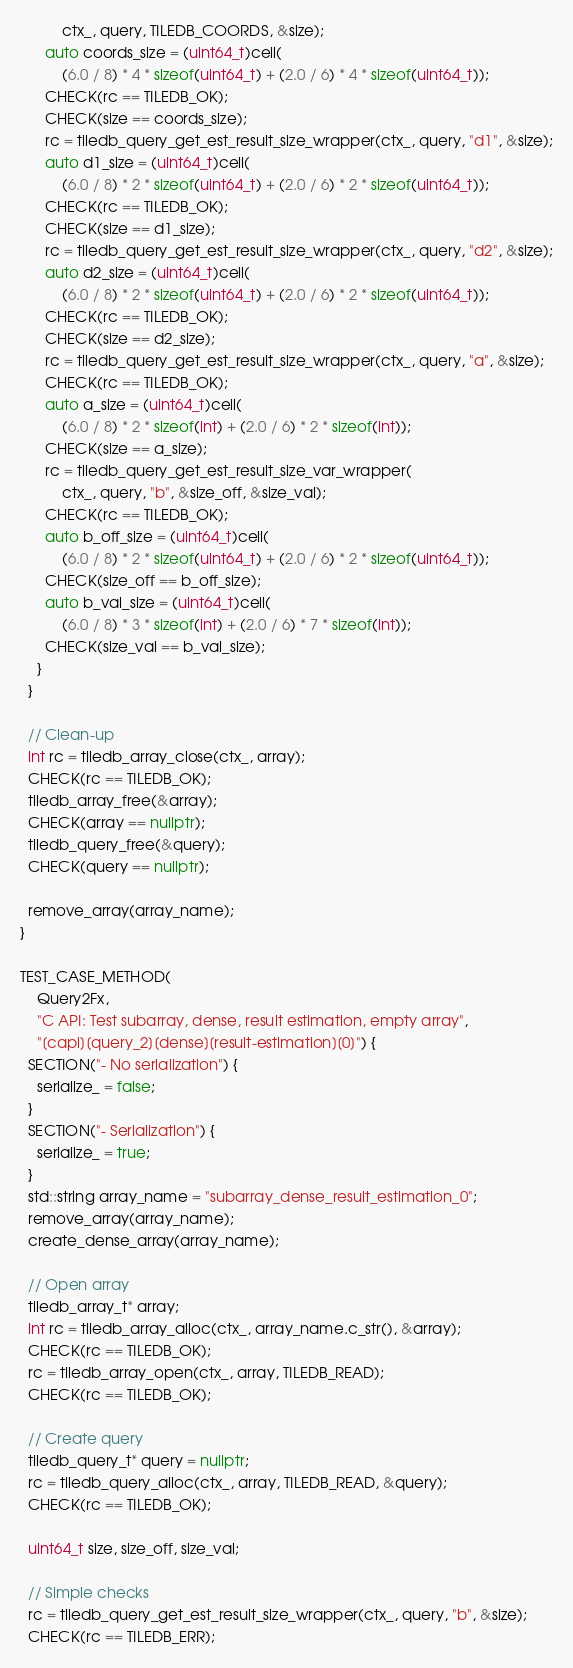Convert code to text. <code><loc_0><loc_0><loc_500><loc_500><_C++_>          ctx_, query, TILEDB_COORDS, &size);
      auto coords_size = (uint64_t)ceil(
          (6.0 / 8) * 4 * sizeof(uint64_t) + (2.0 / 6) * 4 * sizeof(uint64_t));
      CHECK(rc == TILEDB_OK);
      CHECK(size == coords_size);
      rc = tiledb_query_get_est_result_size_wrapper(ctx_, query, "d1", &size);
      auto d1_size = (uint64_t)ceil(
          (6.0 / 8) * 2 * sizeof(uint64_t) + (2.0 / 6) * 2 * sizeof(uint64_t));
      CHECK(rc == TILEDB_OK);
      CHECK(size == d1_size);
      rc = tiledb_query_get_est_result_size_wrapper(ctx_, query, "d2", &size);
      auto d2_size = (uint64_t)ceil(
          (6.0 / 8) * 2 * sizeof(uint64_t) + (2.0 / 6) * 2 * sizeof(uint64_t));
      CHECK(rc == TILEDB_OK);
      CHECK(size == d2_size);
      rc = tiledb_query_get_est_result_size_wrapper(ctx_, query, "a", &size);
      CHECK(rc == TILEDB_OK);
      auto a_size = (uint64_t)ceil(
          (6.0 / 8) * 2 * sizeof(int) + (2.0 / 6) * 2 * sizeof(int));
      CHECK(size == a_size);
      rc = tiledb_query_get_est_result_size_var_wrapper(
          ctx_, query, "b", &size_off, &size_val);
      CHECK(rc == TILEDB_OK);
      auto b_off_size = (uint64_t)ceil(
          (6.0 / 8) * 2 * sizeof(uint64_t) + (2.0 / 6) * 2 * sizeof(uint64_t));
      CHECK(size_off == b_off_size);
      auto b_val_size = (uint64_t)ceil(
          (6.0 / 8) * 3 * sizeof(int) + (2.0 / 6) * 7 * sizeof(int));
      CHECK(size_val == b_val_size);
    }
  }

  // Clean-up
  int rc = tiledb_array_close(ctx_, array);
  CHECK(rc == TILEDB_OK);
  tiledb_array_free(&array);
  CHECK(array == nullptr);
  tiledb_query_free(&query);
  CHECK(query == nullptr);

  remove_array(array_name);
}

TEST_CASE_METHOD(
    Query2Fx,
    "C API: Test subarray, dense, result estimation, empty array",
    "[capi][query_2][dense][result-estimation][0]") {
  SECTION("- No serialization") {
    serialize_ = false;
  }
  SECTION("- Serialization") {
    serialize_ = true;
  }
  std::string array_name = "subarray_dense_result_estimation_0";
  remove_array(array_name);
  create_dense_array(array_name);

  // Open array
  tiledb_array_t* array;
  int rc = tiledb_array_alloc(ctx_, array_name.c_str(), &array);
  CHECK(rc == TILEDB_OK);
  rc = tiledb_array_open(ctx_, array, TILEDB_READ);
  CHECK(rc == TILEDB_OK);

  // Create query
  tiledb_query_t* query = nullptr;
  rc = tiledb_query_alloc(ctx_, array, TILEDB_READ, &query);
  CHECK(rc == TILEDB_OK);

  uint64_t size, size_off, size_val;

  // Simple checks
  rc = tiledb_query_get_est_result_size_wrapper(ctx_, query, "b", &size);
  CHECK(rc == TILEDB_ERR);</code> 